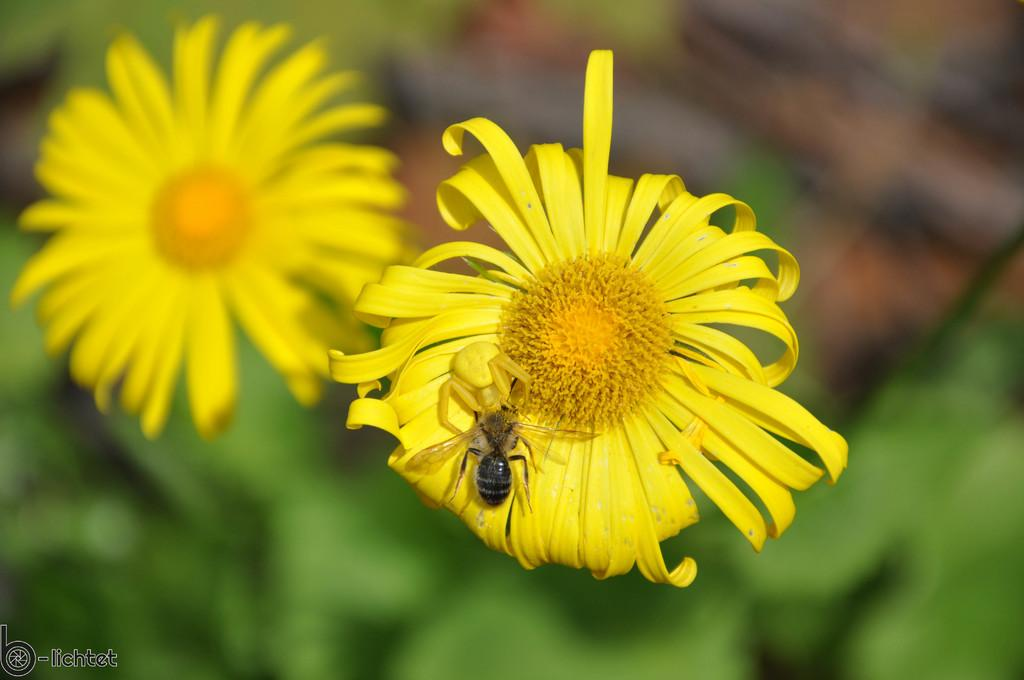What type of creature can be seen in the image? There is an insect in the image. What other elements are present in the image besides the insect? There are flowers in the image. How would you describe the background of the image? The background of the image is blurry. What can be found in the bottom left corner of the image? There is a logo and some text in the bottom left corner of the image. Can you see a clam attached to the insect in the image? There is no clam present in the image, and the insect is not interacting with any clams. What type of space-related object can be seen in the image? There is no space-related object present in the image; it features an insect and flowers. 